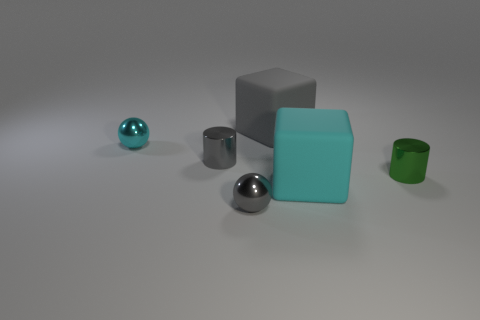Add 3 small cyan spheres. How many objects exist? 9 Subtract all cubes. How many objects are left? 4 Subtract all cyan blocks. How many blocks are left? 1 Subtract 1 balls. How many balls are left? 1 Add 4 green cylinders. How many green cylinders are left? 5 Add 4 big cubes. How many big cubes exist? 6 Subtract 0 blue blocks. How many objects are left? 6 Subtract all cyan blocks. Subtract all gray balls. How many blocks are left? 1 Subtract all brown spheres. Subtract all tiny gray cylinders. How many objects are left? 5 